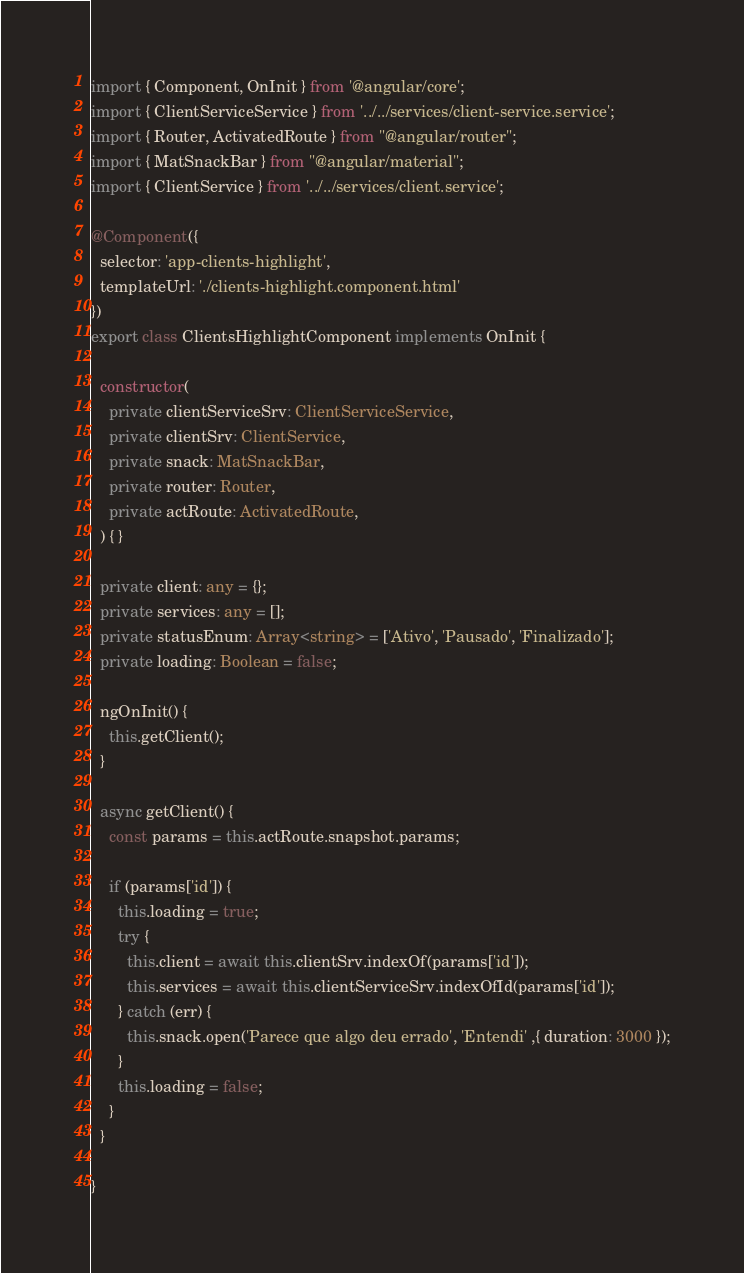Convert code to text. <code><loc_0><loc_0><loc_500><loc_500><_TypeScript_>import { Component, OnInit } from '@angular/core';
import { ClientServiceService } from '../../services/client-service.service';
import { Router, ActivatedRoute } from "@angular/router";
import { MatSnackBar } from "@angular/material";
import { ClientService } from '../../services/client.service';

@Component({
  selector: 'app-clients-highlight',
  templateUrl: './clients-highlight.component.html'
})
export class ClientsHighlightComponent implements OnInit {

  constructor(
    private clientServiceSrv: ClientServiceService,
    private clientSrv: ClientService,
    private snack: MatSnackBar,
    private router: Router,
    private actRoute: ActivatedRoute,
  ) { }

  private client: any = {};
  private services: any = [];
  private statusEnum: Array<string> = ['Ativo', 'Pausado', 'Finalizado'];
  private loading: Boolean = false;

  ngOnInit() {
    this.getClient();
  }

  async getClient() {
    const params = this.actRoute.snapshot.params;

    if (params['id']) {
      this.loading = true;
      try {
        this.client = await this.clientSrv.indexOf(params['id']);
        this.services = await this.clientServiceSrv.indexOfId(params['id']);
      } catch (err) {
        this.snack.open('Parece que algo deu errado', 'Entendi' ,{ duration: 3000 });
      }
      this.loading = false;
    }
  }

}
</code> 